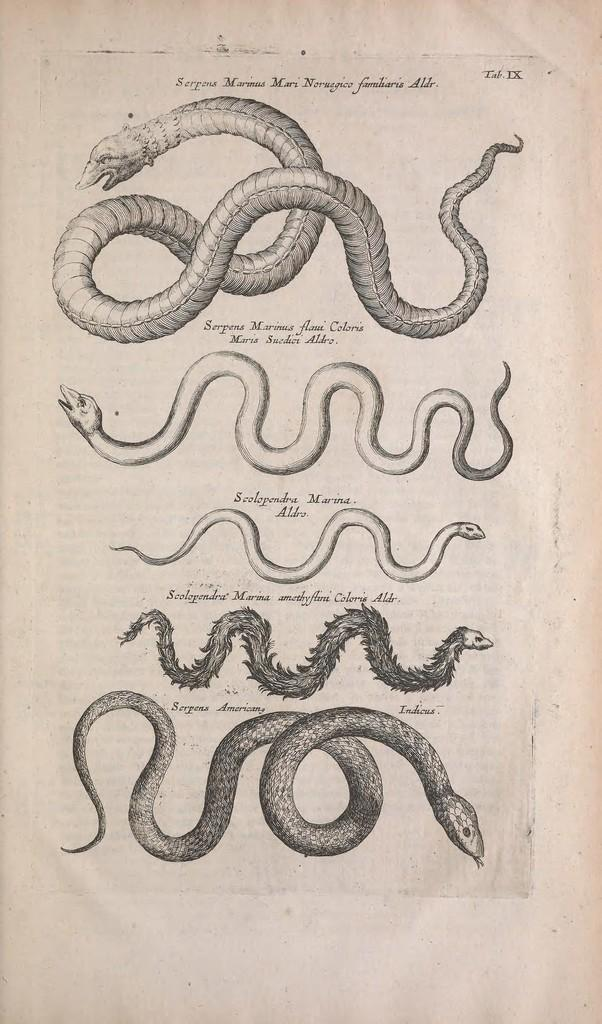What is present on the paper in the image? There is a drawing on the paper. Can you describe the drawing on the paper? Unfortunately, the facts provided do not give enough detail to describe the drawing. What is the primary purpose of the paper in the image? The primary purpose of the paper in the image is to display the drawing. What type of wine is being served in the image? There is no wine present in the image; it only features a paper with a drawing on it. 